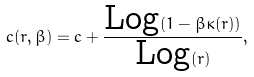Convert formula to latex. <formula><loc_0><loc_0><loc_500><loc_500>c ( r , \beta ) = c + \frac { \text {Log} ( 1 - \beta \kappa ( r ) ) } { \text {Log} ( r ) } ,</formula> 